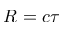<formula> <loc_0><loc_0><loc_500><loc_500>R = c \tau</formula> 